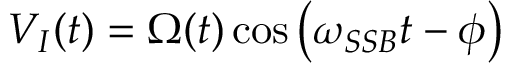<formula> <loc_0><loc_0><loc_500><loc_500>V _ { I } ( t ) = \Omega ( t ) \cos \left ( \omega _ { S S B } t - \phi \right )</formula> 